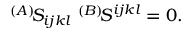Convert formula to latex. <formula><loc_0><loc_0><loc_500><loc_500>{ } ^ { ( A ) } \, S _ { i j k l } \quad \, ^ { ( B ) } \, S ^ { i j k l } = 0 .</formula> 